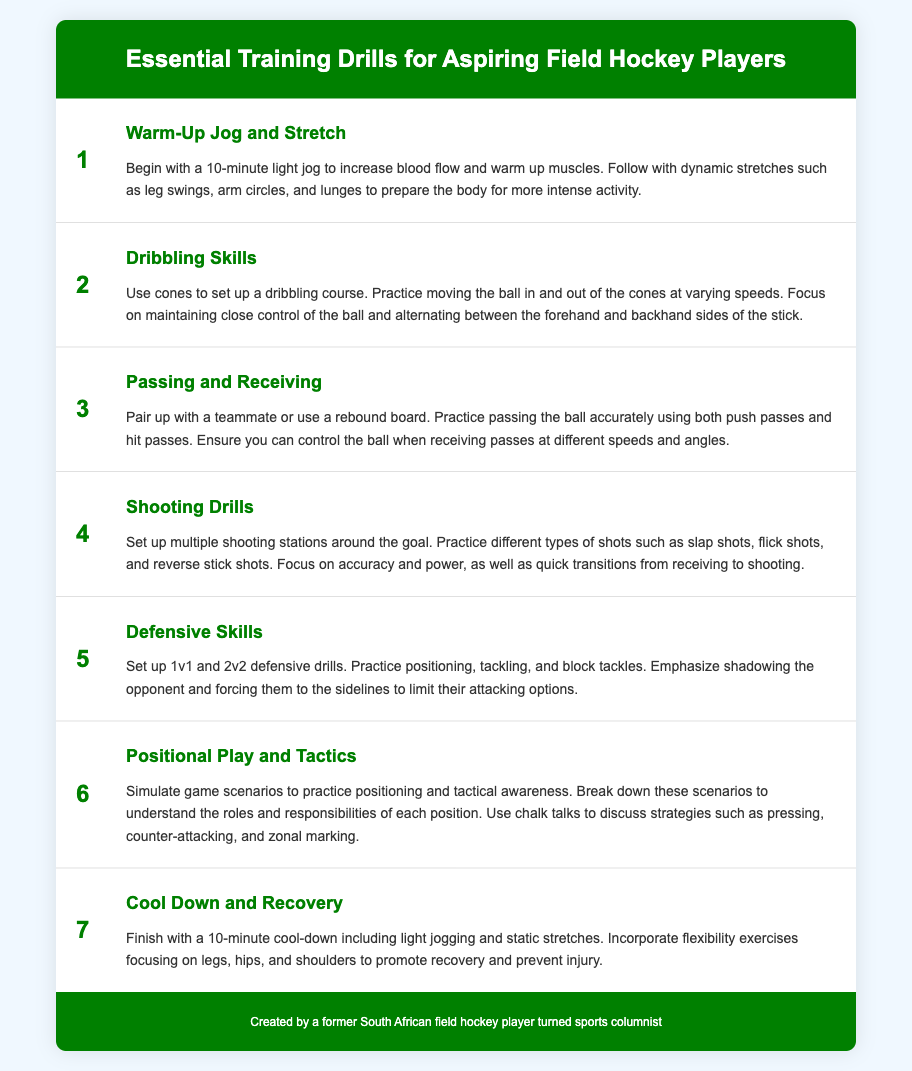What is the first drill listed? The first drill in the list is "Warm-Up Jog and Stretch," which prepares the body for more intense activity.
Answer: Warm-Up Jog and Stretch How many shooting stations are suggested? The document mentions setting up multiple shooting stations around the goal for practice.
Answer: Multiple What is emphasized in the Defensive Skills drill? The Defensive Skills drill emphasizes shadowing the opponent and forcing them to the sidelines.
Answer: Shadowing What type of passes are practiced in the Passing and Receiving drill? The drill practices both push passes and hit passes for accurate passing.
Answer: Push passes and hit passes What is the purpose of the Cool Down and Recovery? The purpose is to promote recovery and prevent injury through light jogging and static stretches.
Answer: Promote recovery What should be included in the Warm-Up Jog and Stretch? The warm-up includes a 10-minute light jog followed by dynamic stretches to prepare the body.
Answer: 10-minute light jog and dynamic stretches Which drill focuses on tactical awareness? The drill focusing on tactical awareness is "Positional Play and Tactics," simulating game scenarios.
Answer: Positional Play and Tactics 